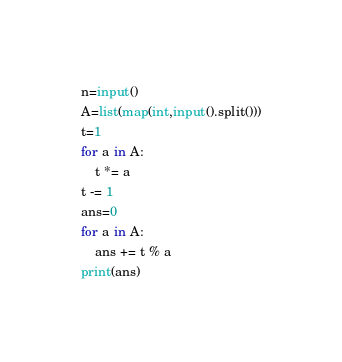<code> <loc_0><loc_0><loc_500><loc_500><_Python_>n=input()
A=list(map(int,input().split()))
t=1
for a in A:
    t *= a
t -= 1
ans=0
for a in A:
    ans += t % a
print(ans)</code> 